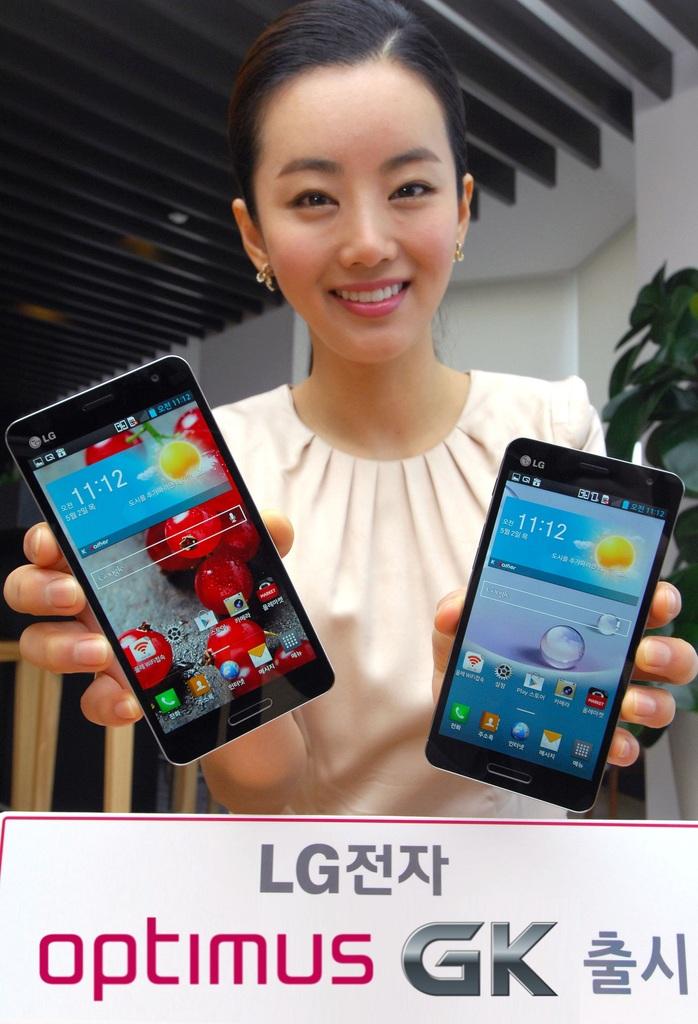What brand of phone?
Offer a terse response. Lg. What time is it?
Give a very brief answer. 11:12. 